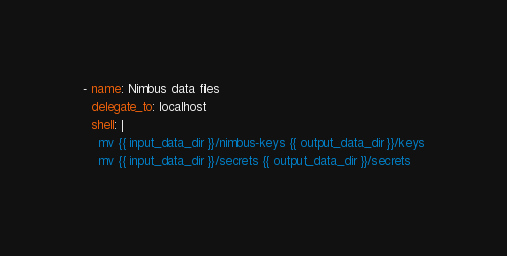Convert code to text. <code><loc_0><loc_0><loc_500><loc_500><_YAML_>- name: Nimbus data files
  delegate_to: localhost
  shell: |
    mv {{ input_data_dir }}/nimbus-keys {{ output_data_dir }}/keys
    mv {{ input_data_dir }}/secrets {{ output_data_dir }}/secrets
</code> 